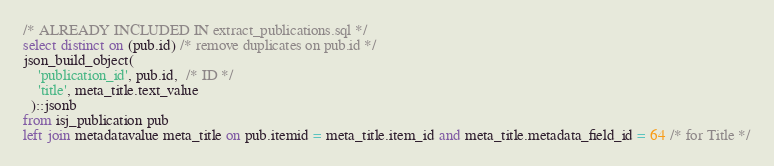<code> <loc_0><loc_0><loc_500><loc_500><_SQL_>/* ALREADY INCLUDED IN extract_publications.sql */
select distinct on (pub.id) /* remove duplicates on pub.id */
json_build_object(
	'publication_id', pub.id,  /* ID */
	'title', meta_title.text_value
  )::jsonb
from isj_publication pub
left join metadatavalue meta_title on pub.itemid = meta_title.item_id and meta_title.metadata_field_id = 64 /* for Title */
</code> 